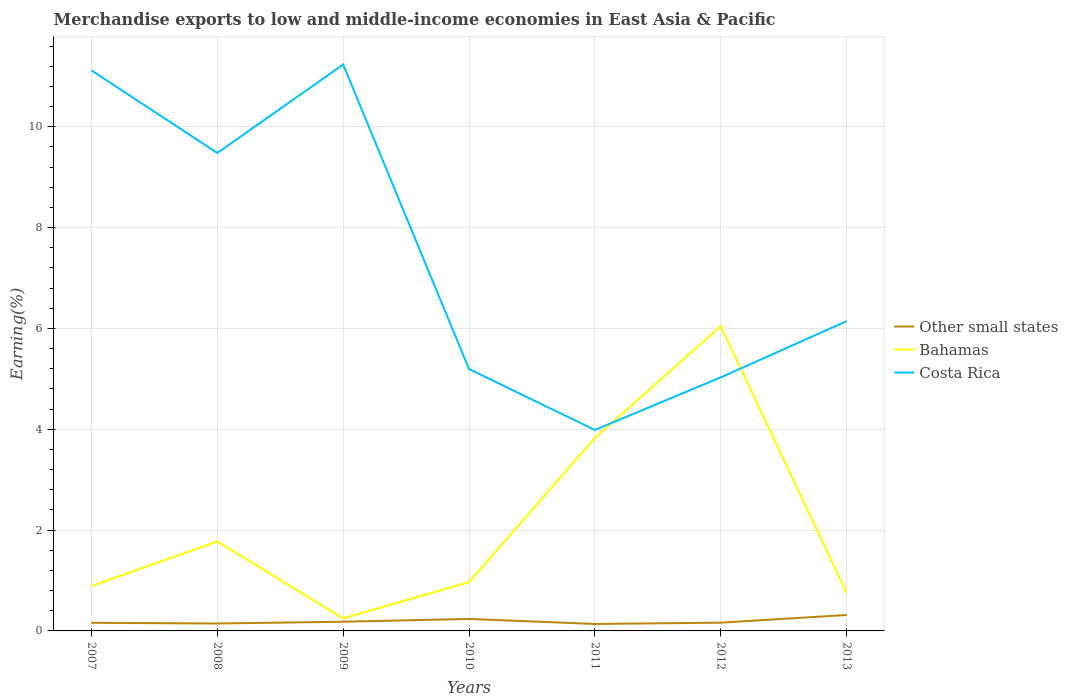How many different coloured lines are there?
Your answer should be compact. 3. Does the line corresponding to Bahamas intersect with the line corresponding to Costa Rica?
Keep it short and to the point. Yes. Is the number of lines equal to the number of legend labels?
Provide a succinct answer. Yes. Across all years, what is the maximum percentage of amount earned from merchandise exports in Bahamas?
Keep it short and to the point. 0.25. In which year was the percentage of amount earned from merchandise exports in Other small states maximum?
Keep it short and to the point. 2011. What is the total percentage of amount earned from merchandise exports in Other small states in the graph?
Your response must be concise. -0.15. What is the difference between the highest and the second highest percentage of amount earned from merchandise exports in Bahamas?
Provide a succinct answer. 5.8. What is the difference between the highest and the lowest percentage of amount earned from merchandise exports in Bahamas?
Provide a succinct answer. 2. How many lines are there?
Provide a succinct answer. 3. How many years are there in the graph?
Offer a very short reply. 7. What is the difference between two consecutive major ticks on the Y-axis?
Ensure brevity in your answer.  2. Where does the legend appear in the graph?
Provide a succinct answer. Center right. How many legend labels are there?
Your response must be concise. 3. How are the legend labels stacked?
Provide a succinct answer. Vertical. What is the title of the graph?
Your answer should be very brief. Merchandise exports to low and middle-income economies in East Asia & Pacific. What is the label or title of the X-axis?
Your answer should be compact. Years. What is the label or title of the Y-axis?
Offer a terse response. Earning(%). What is the Earning(%) of Other small states in 2007?
Offer a terse response. 0.16. What is the Earning(%) of Bahamas in 2007?
Offer a very short reply. 0.89. What is the Earning(%) of Costa Rica in 2007?
Provide a short and direct response. 11.12. What is the Earning(%) of Other small states in 2008?
Your response must be concise. 0.15. What is the Earning(%) in Bahamas in 2008?
Offer a very short reply. 1.78. What is the Earning(%) of Costa Rica in 2008?
Ensure brevity in your answer.  9.48. What is the Earning(%) of Other small states in 2009?
Make the answer very short. 0.18. What is the Earning(%) in Bahamas in 2009?
Offer a very short reply. 0.25. What is the Earning(%) in Costa Rica in 2009?
Ensure brevity in your answer.  11.24. What is the Earning(%) in Other small states in 2010?
Provide a short and direct response. 0.24. What is the Earning(%) in Bahamas in 2010?
Give a very brief answer. 0.97. What is the Earning(%) of Costa Rica in 2010?
Keep it short and to the point. 5.2. What is the Earning(%) of Other small states in 2011?
Keep it short and to the point. 0.14. What is the Earning(%) of Bahamas in 2011?
Make the answer very short. 3.83. What is the Earning(%) in Costa Rica in 2011?
Keep it short and to the point. 3.99. What is the Earning(%) of Other small states in 2012?
Your response must be concise. 0.16. What is the Earning(%) in Bahamas in 2012?
Provide a succinct answer. 6.05. What is the Earning(%) of Costa Rica in 2012?
Offer a terse response. 5.03. What is the Earning(%) of Other small states in 2013?
Your answer should be compact. 0.32. What is the Earning(%) in Bahamas in 2013?
Offer a terse response. 0.76. What is the Earning(%) in Costa Rica in 2013?
Provide a succinct answer. 6.14. Across all years, what is the maximum Earning(%) of Other small states?
Provide a short and direct response. 0.32. Across all years, what is the maximum Earning(%) of Bahamas?
Provide a succinct answer. 6.05. Across all years, what is the maximum Earning(%) of Costa Rica?
Provide a succinct answer. 11.24. Across all years, what is the minimum Earning(%) of Other small states?
Provide a succinct answer. 0.14. Across all years, what is the minimum Earning(%) in Bahamas?
Your answer should be very brief. 0.25. Across all years, what is the minimum Earning(%) of Costa Rica?
Offer a very short reply. 3.99. What is the total Earning(%) of Other small states in the graph?
Offer a very short reply. 1.35. What is the total Earning(%) in Bahamas in the graph?
Provide a succinct answer. 14.51. What is the total Earning(%) in Costa Rica in the graph?
Provide a succinct answer. 52.19. What is the difference between the Earning(%) of Other small states in 2007 and that in 2008?
Offer a very short reply. 0.01. What is the difference between the Earning(%) of Bahamas in 2007 and that in 2008?
Provide a short and direct response. -0.88. What is the difference between the Earning(%) of Costa Rica in 2007 and that in 2008?
Provide a short and direct response. 1.64. What is the difference between the Earning(%) of Other small states in 2007 and that in 2009?
Ensure brevity in your answer.  -0.02. What is the difference between the Earning(%) in Bahamas in 2007 and that in 2009?
Your answer should be compact. 0.64. What is the difference between the Earning(%) of Costa Rica in 2007 and that in 2009?
Offer a terse response. -0.12. What is the difference between the Earning(%) of Other small states in 2007 and that in 2010?
Ensure brevity in your answer.  -0.08. What is the difference between the Earning(%) of Bahamas in 2007 and that in 2010?
Provide a succinct answer. -0.08. What is the difference between the Earning(%) of Costa Rica in 2007 and that in 2010?
Provide a succinct answer. 5.92. What is the difference between the Earning(%) in Other small states in 2007 and that in 2011?
Your response must be concise. 0.02. What is the difference between the Earning(%) in Bahamas in 2007 and that in 2011?
Your answer should be very brief. -2.94. What is the difference between the Earning(%) of Costa Rica in 2007 and that in 2011?
Your answer should be compact. 7.13. What is the difference between the Earning(%) in Other small states in 2007 and that in 2012?
Make the answer very short. -0. What is the difference between the Earning(%) in Bahamas in 2007 and that in 2012?
Offer a very short reply. -5.16. What is the difference between the Earning(%) in Costa Rica in 2007 and that in 2012?
Your answer should be compact. 6.09. What is the difference between the Earning(%) of Other small states in 2007 and that in 2013?
Your answer should be very brief. -0.15. What is the difference between the Earning(%) of Bahamas in 2007 and that in 2013?
Offer a very short reply. 0.13. What is the difference between the Earning(%) of Costa Rica in 2007 and that in 2013?
Provide a succinct answer. 4.97. What is the difference between the Earning(%) of Other small states in 2008 and that in 2009?
Your answer should be compact. -0.04. What is the difference between the Earning(%) of Bahamas in 2008 and that in 2009?
Your answer should be very brief. 1.53. What is the difference between the Earning(%) in Costa Rica in 2008 and that in 2009?
Keep it short and to the point. -1.75. What is the difference between the Earning(%) of Other small states in 2008 and that in 2010?
Your answer should be very brief. -0.09. What is the difference between the Earning(%) in Bahamas in 2008 and that in 2010?
Provide a succinct answer. 0.81. What is the difference between the Earning(%) in Costa Rica in 2008 and that in 2010?
Make the answer very short. 4.29. What is the difference between the Earning(%) in Other small states in 2008 and that in 2011?
Your answer should be very brief. 0.01. What is the difference between the Earning(%) of Bahamas in 2008 and that in 2011?
Keep it short and to the point. -2.05. What is the difference between the Earning(%) of Costa Rica in 2008 and that in 2011?
Offer a very short reply. 5.49. What is the difference between the Earning(%) of Other small states in 2008 and that in 2012?
Your response must be concise. -0.02. What is the difference between the Earning(%) of Bahamas in 2008 and that in 2012?
Offer a very short reply. -4.27. What is the difference between the Earning(%) in Costa Rica in 2008 and that in 2012?
Your answer should be compact. 4.45. What is the difference between the Earning(%) in Other small states in 2008 and that in 2013?
Your answer should be very brief. -0.17. What is the difference between the Earning(%) in Bahamas in 2008 and that in 2013?
Offer a terse response. 1.02. What is the difference between the Earning(%) of Costa Rica in 2008 and that in 2013?
Your answer should be compact. 3.34. What is the difference between the Earning(%) in Other small states in 2009 and that in 2010?
Provide a succinct answer. -0.06. What is the difference between the Earning(%) of Bahamas in 2009 and that in 2010?
Your answer should be very brief. -0.72. What is the difference between the Earning(%) of Costa Rica in 2009 and that in 2010?
Make the answer very short. 6.04. What is the difference between the Earning(%) in Other small states in 2009 and that in 2011?
Your answer should be very brief. 0.04. What is the difference between the Earning(%) of Bahamas in 2009 and that in 2011?
Keep it short and to the point. -3.58. What is the difference between the Earning(%) of Costa Rica in 2009 and that in 2011?
Offer a very short reply. 7.25. What is the difference between the Earning(%) in Other small states in 2009 and that in 2012?
Your response must be concise. 0.02. What is the difference between the Earning(%) of Bahamas in 2009 and that in 2012?
Give a very brief answer. -5.8. What is the difference between the Earning(%) in Costa Rica in 2009 and that in 2012?
Your answer should be very brief. 6.21. What is the difference between the Earning(%) of Other small states in 2009 and that in 2013?
Give a very brief answer. -0.13. What is the difference between the Earning(%) in Bahamas in 2009 and that in 2013?
Provide a succinct answer. -0.51. What is the difference between the Earning(%) of Costa Rica in 2009 and that in 2013?
Ensure brevity in your answer.  5.09. What is the difference between the Earning(%) of Other small states in 2010 and that in 2011?
Provide a succinct answer. 0.1. What is the difference between the Earning(%) of Bahamas in 2010 and that in 2011?
Your answer should be very brief. -2.86. What is the difference between the Earning(%) in Costa Rica in 2010 and that in 2011?
Your answer should be compact. 1.21. What is the difference between the Earning(%) in Other small states in 2010 and that in 2012?
Offer a terse response. 0.07. What is the difference between the Earning(%) of Bahamas in 2010 and that in 2012?
Give a very brief answer. -5.08. What is the difference between the Earning(%) of Costa Rica in 2010 and that in 2012?
Offer a very short reply. 0.17. What is the difference between the Earning(%) of Other small states in 2010 and that in 2013?
Offer a terse response. -0.08. What is the difference between the Earning(%) of Bahamas in 2010 and that in 2013?
Offer a very short reply. 0.21. What is the difference between the Earning(%) of Costa Rica in 2010 and that in 2013?
Keep it short and to the point. -0.95. What is the difference between the Earning(%) in Other small states in 2011 and that in 2012?
Make the answer very short. -0.03. What is the difference between the Earning(%) in Bahamas in 2011 and that in 2012?
Offer a terse response. -2.22. What is the difference between the Earning(%) of Costa Rica in 2011 and that in 2012?
Provide a succinct answer. -1.04. What is the difference between the Earning(%) of Other small states in 2011 and that in 2013?
Offer a very short reply. -0.18. What is the difference between the Earning(%) in Bahamas in 2011 and that in 2013?
Offer a very short reply. 3.07. What is the difference between the Earning(%) in Costa Rica in 2011 and that in 2013?
Your answer should be very brief. -2.16. What is the difference between the Earning(%) in Other small states in 2012 and that in 2013?
Your answer should be very brief. -0.15. What is the difference between the Earning(%) in Bahamas in 2012 and that in 2013?
Your answer should be compact. 5.29. What is the difference between the Earning(%) in Costa Rica in 2012 and that in 2013?
Offer a very short reply. -1.11. What is the difference between the Earning(%) of Other small states in 2007 and the Earning(%) of Bahamas in 2008?
Your response must be concise. -1.61. What is the difference between the Earning(%) in Other small states in 2007 and the Earning(%) in Costa Rica in 2008?
Your answer should be compact. -9.32. What is the difference between the Earning(%) in Bahamas in 2007 and the Earning(%) in Costa Rica in 2008?
Offer a very short reply. -8.59. What is the difference between the Earning(%) in Other small states in 2007 and the Earning(%) in Bahamas in 2009?
Provide a short and direct response. -0.09. What is the difference between the Earning(%) of Other small states in 2007 and the Earning(%) of Costa Rica in 2009?
Your response must be concise. -11.07. What is the difference between the Earning(%) of Bahamas in 2007 and the Earning(%) of Costa Rica in 2009?
Offer a terse response. -10.35. What is the difference between the Earning(%) in Other small states in 2007 and the Earning(%) in Bahamas in 2010?
Provide a short and direct response. -0.81. What is the difference between the Earning(%) of Other small states in 2007 and the Earning(%) of Costa Rica in 2010?
Keep it short and to the point. -5.03. What is the difference between the Earning(%) in Bahamas in 2007 and the Earning(%) in Costa Rica in 2010?
Your answer should be compact. -4.31. What is the difference between the Earning(%) in Other small states in 2007 and the Earning(%) in Bahamas in 2011?
Keep it short and to the point. -3.67. What is the difference between the Earning(%) in Other small states in 2007 and the Earning(%) in Costa Rica in 2011?
Offer a terse response. -3.83. What is the difference between the Earning(%) in Bahamas in 2007 and the Earning(%) in Costa Rica in 2011?
Give a very brief answer. -3.1. What is the difference between the Earning(%) in Other small states in 2007 and the Earning(%) in Bahamas in 2012?
Provide a short and direct response. -5.88. What is the difference between the Earning(%) in Other small states in 2007 and the Earning(%) in Costa Rica in 2012?
Make the answer very short. -4.87. What is the difference between the Earning(%) of Bahamas in 2007 and the Earning(%) of Costa Rica in 2012?
Your answer should be very brief. -4.14. What is the difference between the Earning(%) of Other small states in 2007 and the Earning(%) of Bahamas in 2013?
Your answer should be compact. -0.6. What is the difference between the Earning(%) in Other small states in 2007 and the Earning(%) in Costa Rica in 2013?
Make the answer very short. -5.98. What is the difference between the Earning(%) in Bahamas in 2007 and the Earning(%) in Costa Rica in 2013?
Offer a terse response. -5.25. What is the difference between the Earning(%) in Other small states in 2008 and the Earning(%) in Bahamas in 2009?
Your answer should be very brief. -0.1. What is the difference between the Earning(%) of Other small states in 2008 and the Earning(%) of Costa Rica in 2009?
Provide a succinct answer. -11.09. What is the difference between the Earning(%) of Bahamas in 2008 and the Earning(%) of Costa Rica in 2009?
Your answer should be very brief. -9.46. What is the difference between the Earning(%) in Other small states in 2008 and the Earning(%) in Bahamas in 2010?
Keep it short and to the point. -0.82. What is the difference between the Earning(%) in Other small states in 2008 and the Earning(%) in Costa Rica in 2010?
Your answer should be compact. -5.05. What is the difference between the Earning(%) in Bahamas in 2008 and the Earning(%) in Costa Rica in 2010?
Your response must be concise. -3.42. What is the difference between the Earning(%) of Other small states in 2008 and the Earning(%) of Bahamas in 2011?
Offer a very short reply. -3.68. What is the difference between the Earning(%) of Other small states in 2008 and the Earning(%) of Costa Rica in 2011?
Your response must be concise. -3.84. What is the difference between the Earning(%) of Bahamas in 2008 and the Earning(%) of Costa Rica in 2011?
Give a very brief answer. -2.21. What is the difference between the Earning(%) of Other small states in 2008 and the Earning(%) of Bahamas in 2012?
Your answer should be compact. -5.9. What is the difference between the Earning(%) in Other small states in 2008 and the Earning(%) in Costa Rica in 2012?
Your response must be concise. -4.88. What is the difference between the Earning(%) in Bahamas in 2008 and the Earning(%) in Costa Rica in 2012?
Provide a short and direct response. -3.25. What is the difference between the Earning(%) of Other small states in 2008 and the Earning(%) of Bahamas in 2013?
Provide a short and direct response. -0.61. What is the difference between the Earning(%) of Other small states in 2008 and the Earning(%) of Costa Rica in 2013?
Offer a terse response. -6. What is the difference between the Earning(%) of Bahamas in 2008 and the Earning(%) of Costa Rica in 2013?
Your response must be concise. -4.37. What is the difference between the Earning(%) in Other small states in 2009 and the Earning(%) in Bahamas in 2010?
Your response must be concise. -0.79. What is the difference between the Earning(%) in Other small states in 2009 and the Earning(%) in Costa Rica in 2010?
Make the answer very short. -5.01. What is the difference between the Earning(%) in Bahamas in 2009 and the Earning(%) in Costa Rica in 2010?
Offer a very short reply. -4.95. What is the difference between the Earning(%) of Other small states in 2009 and the Earning(%) of Bahamas in 2011?
Your answer should be very brief. -3.65. What is the difference between the Earning(%) in Other small states in 2009 and the Earning(%) in Costa Rica in 2011?
Give a very brief answer. -3.8. What is the difference between the Earning(%) of Bahamas in 2009 and the Earning(%) of Costa Rica in 2011?
Provide a succinct answer. -3.74. What is the difference between the Earning(%) of Other small states in 2009 and the Earning(%) of Bahamas in 2012?
Keep it short and to the point. -5.86. What is the difference between the Earning(%) of Other small states in 2009 and the Earning(%) of Costa Rica in 2012?
Make the answer very short. -4.85. What is the difference between the Earning(%) of Bahamas in 2009 and the Earning(%) of Costa Rica in 2012?
Your answer should be very brief. -4.78. What is the difference between the Earning(%) in Other small states in 2009 and the Earning(%) in Bahamas in 2013?
Your answer should be compact. -0.57. What is the difference between the Earning(%) of Other small states in 2009 and the Earning(%) of Costa Rica in 2013?
Offer a very short reply. -5.96. What is the difference between the Earning(%) of Bahamas in 2009 and the Earning(%) of Costa Rica in 2013?
Offer a very short reply. -5.89. What is the difference between the Earning(%) of Other small states in 2010 and the Earning(%) of Bahamas in 2011?
Your answer should be compact. -3.59. What is the difference between the Earning(%) of Other small states in 2010 and the Earning(%) of Costa Rica in 2011?
Provide a succinct answer. -3.75. What is the difference between the Earning(%) of Bahamas in 2010 and the Earning(%) of Costa Rica in 2011?
Offer a terse response. -3.02. What is the difference between the Earning(%) of Other small states in 2010 and the Earning(%) of Bahamas in 2012?
Offer a terse response. -5.81. What is the difference between the Earning(%) in Other small states in 2010 and the Earning(%) in Costa Rica in 2012?
Your response must be concise. -4.79. What is the difference between the Earning(%) in Bahamas in 2010 and the Earning(%) in Costa Rica in 2012?
Offer a terse response. -4.06. What is the difference between the Earning(%) in Other small states in 2010 and the Earning(%) in Bahamas in 2013?
Your answer should be compact. -0.52. What is the difference between the Earning(%) in Other small states in 2010 and the Earning(%) in Costa Rica in 2013?
Make the answer very short. -5.91. What is the difference between the Earning(%) of Bahamas in 2010 and the Earning(%) of Costa Rica in 2013?
Give a very brief answer. -5.18. What is the difference between the Earning(%) of Other small states in 2011 and the Earning(%) of Bahamas in 2012?
Offer a very short reply. -5.91. What is the difference between the Earning(%) in Other small states in 2011 and the Earning(%) in Costa Rica in 2012?
Offer a very short reply. -4.89. What is the difference between the Earning(%) of Bahamas in 2011 and the Earning(%) of Costa Rica in 2012?
Ensure brevity in your answer.  -1.2. What is the difference between the Earning(%) in Other small states in 2011 and the Earning(%) in Bahamas in 2013?
Keep it short and to the point. -0.62. What is the difference between the Earning(%) of Other small states in 2011 and the Earning(%) of Costa Rica in 2013?
Give a very brief answer. -6.01. What is the difference between the Earning(%) of Bahamas in 2011 and the Earning(%) of Costa Rica in 2013?
Make the answer very short. -2.32. What is the difference between the Earning(%) in Other small states in 2012 and the Earning(%) in Bahamas in 2013?
Your answer should be compact. -0.59. What is the difference between the Earning(%) in Other small states in 2012 and the Earning(%) in Costa Rica in 2013?
Offer a terse response. -5.98. What is the difference between the Earning(%) in Bahamas in 2012 and the Earning(%) in Costa Rica in 2013?
Offer a terse response. -0.1. What is the average Earning(%) of Other small states per year?
Offer a terse response. 0.19. What is the average Earning(%) in Bahamas per year?
Offer a very short reply. 2.07. What is the average Earning(%) of Costa Rica per year?
Your answer should be compact. 7.46. In the year 2007, what is the difference between the Earning(%) in Other small states and Earning(%) in Bahamas?
Your answer should be very brief. -0.73. In the year 2007, what is the difference between the Earning(%) in Other small states and Earning(%) in Costa Rica?
Give a very brief answer. -10.96. In the year 2007, what is the difference between the Earning(%) in Bahamas and Earning(%) in Costa Rica?
Provide a short and direct response. -10.23. In the year 2008, what is the difference between the Earning(%) in Other small states and Earning(%) in Bahamas?
Your response must be concise. -1.63. In the year 2008, what is the difference between the Earning(%) of Other small states and Earning(%) of Costa Rica?
Ensure brevity in your answer.  -9.33. In the year 2008, what is the difference between the Earning(%) of Bahamas and Earning(%) of Costa Rica?
Give a very brief answer. -7.71. In the year 2009, what is the difference between the Earning(%) of Other small states and Earning(%) of Bahamas?
Offer a terse response. -0.07. In the year 2009, what is the difference between the Earning(%) of Other small states and Earning(%) of Costa Rica?
Keep it short and to the point. -11.05. In the year 2009, what is the difference between the Earning(%) of Bahamas and Earning(%) of Costa Rica?
Ensure brevity in your answer.  -10.99. In the year 2010, what is the difference between the Earning(%) in Other small states and Earning(%) in Bahamas?
Ensure brevity in your answer.  -0.73. In the year 2010, what is the difference between the Earning(%) of Other small states and Earning(%) of Costa Rica?
Make the answer very short. -4.96. In the year 2010, what is the difference between the Earning(%) of Bahamas and Earning(%) of Costa Rica?
Offer a terse response. -4.23. In the year 2011, what is the difference between the Earning(%) in Other small states and Earning(%) in Bahamas?
Offer a very short reply. -3.69. In the year 2011, what is the difference between the Earning(%) of Other small states and Earning(%) of Costa Rica?
Your answer should be very brief. -3.85. In the year 2011, what is the difference between the Earning(%) in Bahamas and Earning(%) in Costa Rica?
Provide a short and direct response. -0.16. In the year 2012, what is the difference between the Earning(%) of Other small states and Earning(%) of Bahamas?
Provide a succinct answer. -5.88. In the year 2012, what is the difference between the Earning(%) in Other small states and Earning(%) in Costa Rica?
Make the answer very short. -4.87. In the year 2013, what is the difference between the Earning(%) of Other small states and Earning(%) of Bahamas?
Your answer should be compact. -0.44. In the year 2013, what is the difference between the Earning(%) in Other small states and Earning(%) in Costa Rica?
Your answer should be very brief. -5.83. In the year 2013, what is the difference between the Earning(%) of Bahamas and Earning(%) of Costa Rica?
Offer a very short reply. -5.39. What is the ratio of the Earning(%) in Other small states in 2007 to that in 2008?
Ensure brevity in your answer.  1.09. What is the ratio of the Earning(%) in Bahamas in 2007 to that in 2008?
Offer a terse response. 0.5. What is the ratio of the Earning(%) in Costa Rica in 2007 to that in 2008?
Keep it short and to the point. 1.17. What is the ratio of the Earning(%) in Other small states in 2007 to that in 2009?
Make the answer very short. 0.88. What is the ratio of the Earning(%) of Bahamas in 2007 to that in 2009?
Offer a terse response. 3.57. What is the ratio of the Earning(%) in Other small states in 2007 to that in 2010?
Give a very brief answer. 0.68. What is the ratio of the Earning(%) of Bahamas in 2007 to that in 2010?
Your answer should be compact. 0.92. What is the ratio of the Earning(%) in Costa Rica in 2007 to that in 2010?
Your answer should be compact. 2.14. What is the ratio of the Earning(%) of Other small states in 2007 to that in 2011?
Keep it short and to the point. 1.17. What is the ratio of the Earning(%) in Bahamas in 2007 to that in 2011?
Offer a terse response. 0.23. What is the ratio of the Earning(%) of Costa Rica in 2007 to that in 2011?
Give a very brief answer. 2.79. What is the ratio of the Earning(%) in Other small states in 2007 to that in 2012?
Provide a succinct answer. 0.98. What is the ratio of the Earning(%) of Bahamas in 2007 to that in 2012?
Your response must be concise. 0.15. What is the ratio of the Earning(%) in Costa Rica in 2007 to that in 2012?
Offer a very short reply. 2.21. What is the ratio of the Earning(%) of Other small states in 2007 to that in 2013?
Offer a very short reply. 0.51. What is the ratio of the Earning(%) in Bahamas in 2007 to that in 2013?
Keep it short and to the point. 1.18. What is the ratio of the Earning(%) in Costa Rica in 2007 to that in 2013?
Offer a very short reply. 1.81. What is the ratio of the Earning(%) in Other small states in 2008 to that in 2009?
Keep it short and to the point. 0.81. What is the ratio of the Earning(%) in Bahamas in 2008 to that in 2009?
Your answer should be very brief. 7.12. What is the ratio of the Earning(%) of Costa Rica in 2008 to that in 2009?
Ensure brevity in your answer.  0.84. What is the ratio of the Earning(%) of Other small states in 2008 to that in 2010?
Provide a succinct answer. 0.62. What is the ratio of the Earning(%) of Bahamas in 2008 to that in 2010?
Make the answer very short. 1.83. What is the ratio of the Earning(%) in Costa Rica in 2008 to that in 2010?
Give a very brief answer. 1.82. What is the ratio of the Earning(%) of Other small states in 2008 to that in 2011?
Keep it short and to the point. 1.07. What is the ratio of the Earning(%) of Bahamas in 2008 to that in 2011?
Make the answer very short. 0.46. What is the ratio of the Earning(%) of Costa Rica in 2008 to that in 2011?
Keep it short and to the point. 2.38. What is the ratio of the Earning(%) in Other small states in 2008 to that in 2012?
Make the answer very short. 0.9. What is the ratio of the Earning(%) in Bahamas in 2008 to that in 2012?
Your response must be concise. 0.29. What is the ratio of the Earning(%) of Costa Rica in 2008 to that in 2012?
Make the answer very short. 1.89. What is the ratio of the Earning(%) of Other small states in 2008 to that in 2013?
Your response must be concise. 0.47. What is the ratio of the Earning(%) in Bahamas in 2008 to that in 2013?
Provide a short and direct response. 2.34. What is the ratio of the Earning(%) of Costa Rica in 2008 to that in 2013?
Your answer should be compact. 1.54. What is the ratio of the Earning(%) of Other small states in 2009 to that in 2010?
Your answer should be compact. 0.77. What is the ratio of the Earning(%) in Bahamas in 2009 to that in 2010?
Provide a succinct answer. 0.26. What is the ratio of the Earning(%) in Costa Rica in 2009 to that in 2010?
Keep it short and to the point. 2.16. What is the ratio of the Earning(%) of Other small states in 2009 to that in 2011?
Offer a terse response. 1.32. What is the ratio of the Earning(%) of Bahamas in 2009 to that in 2011?
Offer a terse response. 0.07. What is the ratio of the Earning(%) of Costa Rica in 2009 to that in 2011?
Keep it short and to the point. 2.82. What is the ratio of the Earning(%) of Other small states in 2009 to that in 2012?
Offer a terse response. 1.11. What is the ratio of the Earning(%) in Bahamas in 2009 to that in 2012?
Your response must be concise. 0.04. What is the ratio of the Earning(%) in Costa Rica in 2009 to that in 2012?
Your response must be concise. 2.23. What is the ratio of the Earning(%) of Other small states in 2009 to that in 2013?
Offer a very short reply. 0.58. What is the ratio of the Earning(%) in Bahamas in 2009 to that in 2013?
Offer a very short reply. 0.33. What is the ratio of the Earning(%) of Costa Rica in 2009 to that in 2013?
Provide a succinct answer. 1.83. What is the ratio of the Earning(%) of Other small states in 2010 to that in 2011?
Provide a short and direct response. 1.72. What is the ratio of the Earning(%) of Bahamas in 2010 to that in 2011?
Your answer should be very brief. 0.25. What is the ratio of the Earning(%) in Costa Rica in 2010 to that in 2011?
Provide a succinct answer. 1.3. What is the ratio of the Earning(%) in Other small states in 2010 to that in 2012?
Provide a short and direct response. 1.45. What is the ratio of the Earning(%) of Bahamas in 2010 to that in 2012?
Keep it short and to the point. 0.16. What is the ratio of the Earning(%) in Costa Rica in 2010 to that in 2012?
Your answer should be compact. 1.03. What is the ratio of the Earning(%) in Other small states in 2010 to that in 2013?
Ensure brevity in your answer.  0.75. What is the ratio of the Earning(%) of Bahamas in 2010 to that in 2013?
Provide a short and direct response. 1.28. What is the ratio of the Earning(%) in Costa Rica in 2010 to that in 2013?
Your answer should be very brief. 0.85. What is the ratio of the Earning(%) of Other small states in 2011 to that in 2012?
Ensure brevity in your answer.  0.84. What is the ratio of the Earning(%) of Bahamas in 2011 to that in 2012?
Offer a terse response. 0.63. What is the ratio of the Earning(%) of Costa Rica in 2011 to that in 2012?
Provide a short and direct response. 0.79. What is the ratio of the Earning(%) of Other small states in 2011 to that in 2013?
Provide a short and direct response. 0.44. What is the ratio of the Earning(%) in Bahamas in 2011 to that in 2013?
Make the answer very short. 5.05. What is the ratio of the Earning(%) of Costa Rica in 2011 to that in 2013?
Provide a succinct answer. 0.65. What is the ratio of the Earning(%) in Other small states in 2012 to that in 2013?
Give a very brief answer. 0.52. What is the ratio of the Earning(%) of Bahamas in 2012 to that in 2013?
Offer a very short reply. 7.98. What is the ratio of the Earning(%) in Costa Rica in 2012 to that in 2013?
Offer a very short reply. 0.82. What is the difference between the highest and the second highest Earning(%) of Other small states?
Keep it short and to the point. 0.08. What is the difference between the highest and the second highest Earning(%) of Bahamas?
Your answer should be compact. 2.22. What is the difference between the highest and the second highest Earning(%) in Costa Rica?
Make the answer very short. 0.12. What is the difference between the highest and the lowest Earning(%) of Other small states?
Provide a succinct answer. 0.18. What is the difference between the highest and the lowest Earning(%) of Bahamas?
Your answer should be very brief. 5.8. What is the difference between the highest and the lowest Earning(%) of Costa Rica?
Keep it short and to the point. 7.25. 